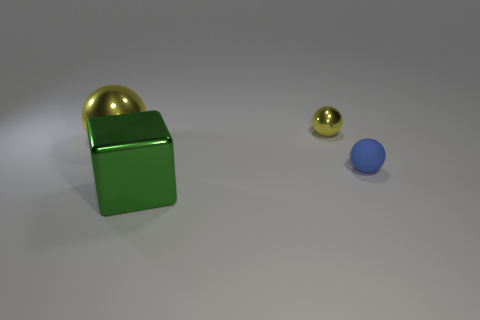Is the number of yellow objects behind the blue ball greater than the number of things that are in front of the tiny metallic ball?
Provide a succinct answer. No. Does the blue matte ball have the same size as the green object?
Provide a succinct answer. No. What is the color of the other tiny object that is the same shape as the matte thing?
Give a very brief answer. Yellow. What number of objects are the same color as the big sphere?
Keep it short and to the point. 1. Is the number of small shiny balls in front of the tiny yellow metal object greater than the number of large cubes?
Offer a very short reply. No. There is a object right of the shiny ball right of the big yellow sphere; what color is it?
Offer a very short reply. Blue. What number of things are balls on the left side of the tiny blue thing or tiny objects that are in front of the small yellow shiny sphere?
Your answer should be compact. 3. What color is the matte sphere?
Keep it short and to the point. Blue. What number of tiny objects have the same material as the large block?
Your answer should be very brief. 1. Is the number of yellow objects greater than the number of small yellow spheres?
Your response must be concise. Yes. 